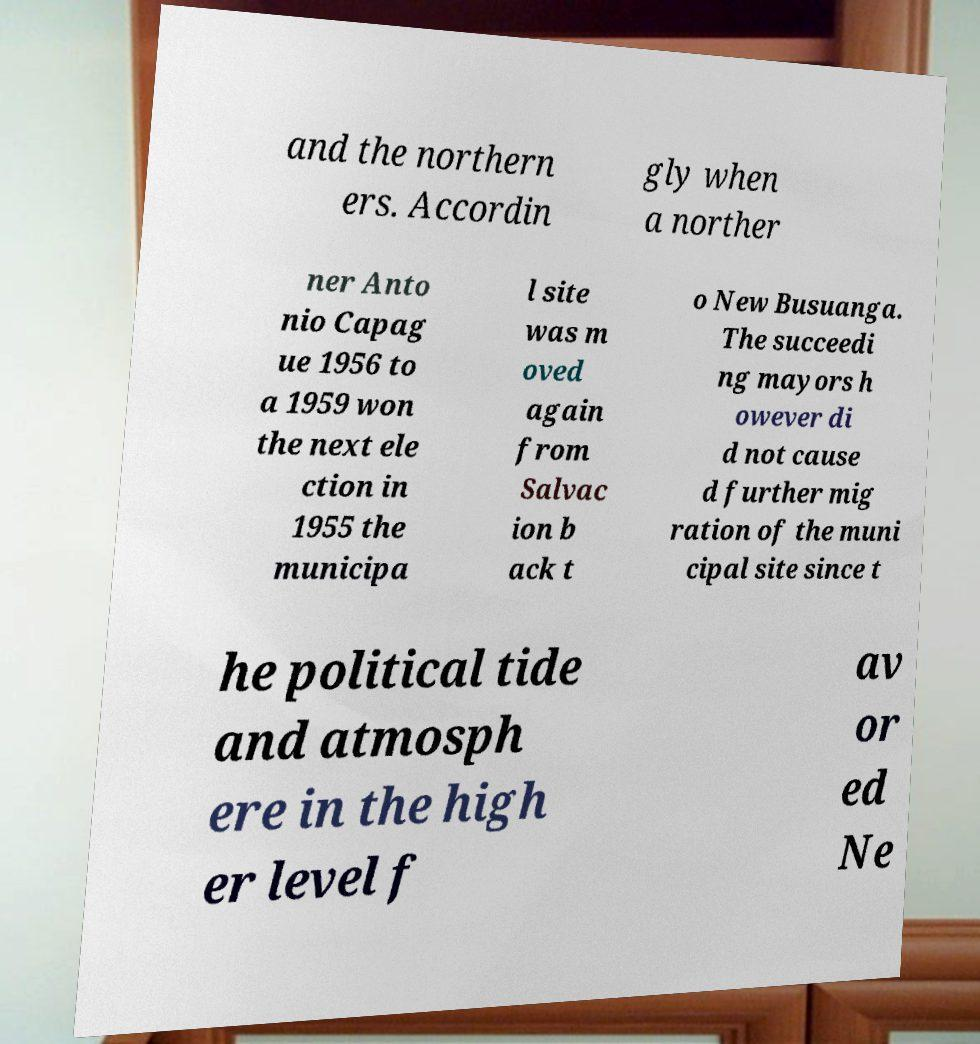Please read and relay the text visible in this image. What does it say? and the northern ers. Accordin gly when a norther ner Anto nio Capag ue 1956 to a 1959 won the next ele ction in 1955 the municipa l site was m oved again from Salvac ion b ack t o New Busuanga. The succeedi ng mayors h owever di d not cause d further mig ration of the muni cipal site since t he political tide and atmosph ere in the high er level f av or ed Ne 